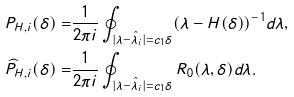Convert formula to latex. <formula><loc_0><loc_0><loc_500><loc_500>P _ { H , i } ( \delta ) = & \frac { 1 } { 2 \pi i } \oint _ { | \lambda - \hat { \lambda } _ { i } | = c _ { 1 } \delta } ( \lambda - H ( \delta ) ) ^ { - 1 } d \lambda , \\ \widehat { P } _ { H , i } ( \delta ) = & \frac { 1 } { 2 \pi i } \oint _ { | \lambda - \hat { \lambda } _ { i } | = c _ { 1 } \delta } R _ { 0 } ( \lambda , \delta ) d \lambda .</formula> 